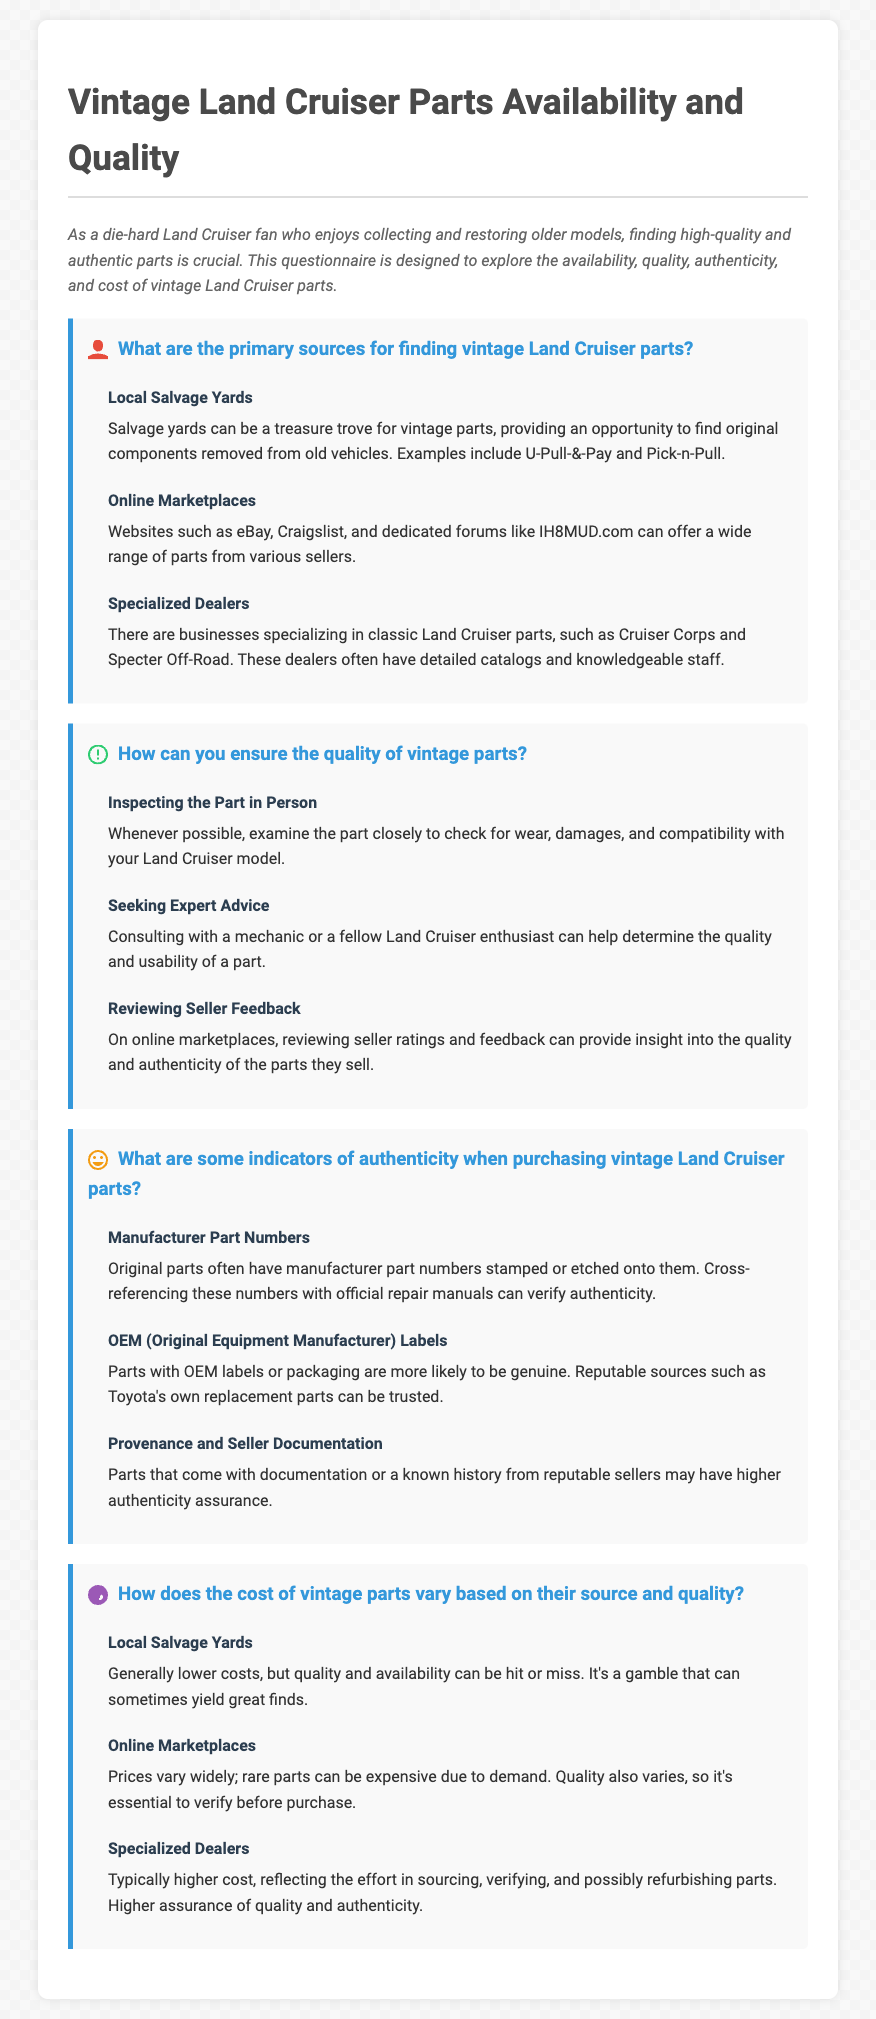What are the primary sources for finding vintage Land Cruiser parts? The document lists Local Salvage Yards, Online Marketplaces, and Specialized Dealers as the primary sources.
Answer: Local Salvage Yards, Online Marketplaces, Specialized Dealers How can you ensure the quality of vintage parts? The document suggests inspecting the part in person, seeking expert advice, and reviewing seller feedback to ensure quality.
Answer: Inspecting the part in person, Seeking expert advice, Reviewing seller feedback What is a way to check for the authenticity of vintage Land Cruiser parts? The document mentions looking for manufacturer part numbers, OEM labels, and provenance documentation as indicators of authenticity.
Answer: Manufacturer part numbers, OEM labels, Provenance and seller documentation What is the typical cost range for parts from local salvage yards? The document states that local salvage yards generally have lower costs, but they can vary in quality and availability.
Answer: Generally lower costs How does the cost of specialized dealers compare to other sources? The document states that specialized dealers typically have higher costs, reflecting their efforts in sourcing and verifying parts.
Answer: Typically higher cost What should you check when purchasing online? The document emphasizes reviewing seller ratings and feedback on online marketplaces to ensure quality.
Answer: Reviewing seller ratings and feedback How can provenance help in assessing a part's authenticity? The document notes that provenance and seller documentation can enhance assurance of authenticity.
Answer: Higher authenticity assurance What is a common drawback of sourcing parts from online marketplaces? The document indicates that prices vary widely and rare parts can be expensive due to demand.
Answer: Prices vary widely, rare parts can be expensive What is mentioned as a good strategy for inspecting parts? The document advises examining the part closely to check for wear and compatibility with your Land Cruiser model.
Answer: Examine the part closely 